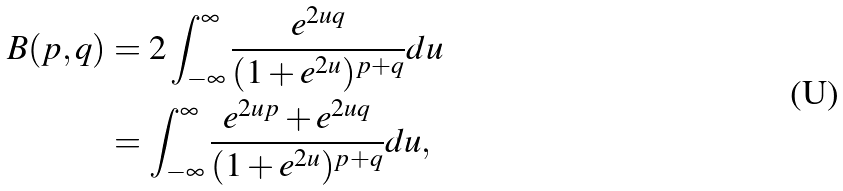Convert formula to latex. <formula><loc_0><loc_0><loc_500><loc_500>\ B ( p , q ) & = 2 \int _ { - \infty } ^ { \infty } \frac { e ^ { 2 u q } } { ( 1 + e ^ { 2 u } ) ^ { p + q } } d u \\ & = \int _ { - \infty } ^ { \infty } \frac { e ^ { 2 u p } + e ^ { 2 u q } } { ( 1 + e ^ { 2 u } ) ^ { p + q } } d u ,</formula> 